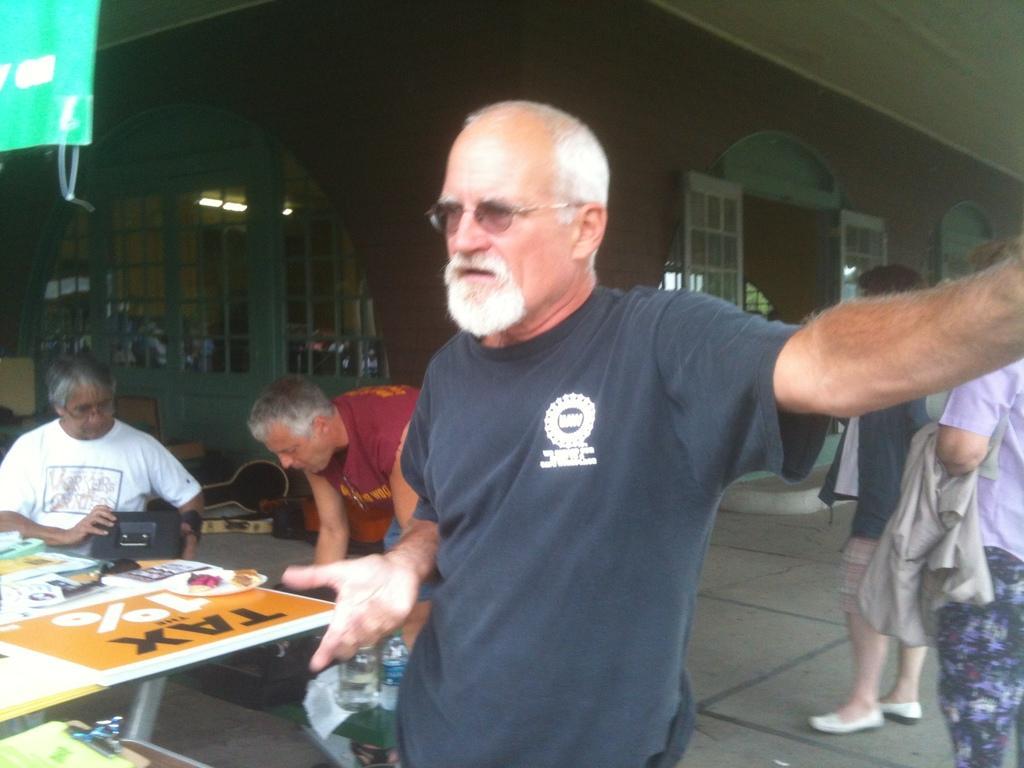Could you give a brief overview of what you see in this image? In the picture we can see a man standing with the blue T-shirt and just beside to him there is a table and some people are sitting on the chairs near to that table, In the background we can see some people are standing and holding a clothes, house building with doors. 